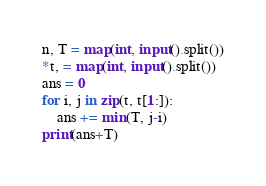<code> <loc_0><loc_0><loc_500><loc_500><_Python_>n, T = map(int, input().split())
*t, = map(int, input().split())
ans = 0
for i, j in zip(t, t[1:]):
    ans += min(T, j-i)
print(ans+T)</code> 